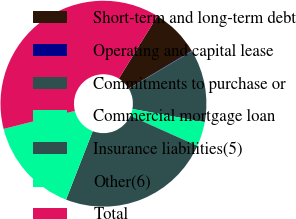Convert chart to OTSL. <chart><loc_0><loc_0><loc_500><loc_500><pie_chart><fcel>Short-term and long-term debt<fcel>Operating and capital lease<fcel>Commitments to purchase or<fcel>Commercial mortgage loan<fcel>Insurance liabilities(5)<fcel>Other(6)<fcel>Total<nl><fcel>7.62%<fcel>0.09%<fcel>11.38%<fcel>3.85%<fcel>24.2%<fcel>15.14%<fcel>37.72%<nl></chart> 